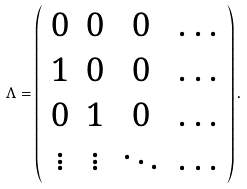Convert formula to latex. <formula><loc_0><loc_0><loc_500><loc_500>\Lambda = \left ( \begin{array} { c c c c } 0 & 0 & 0 & \dots \\ 1 & 0 & 0 & \dots \\ 0 & 1 & 0 & \dots \\ \vdots & \vdots & \ddots & \dots \end{array} \right ) .</formula> 